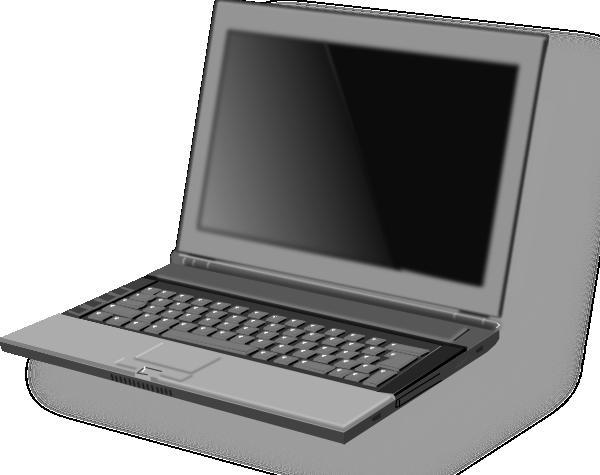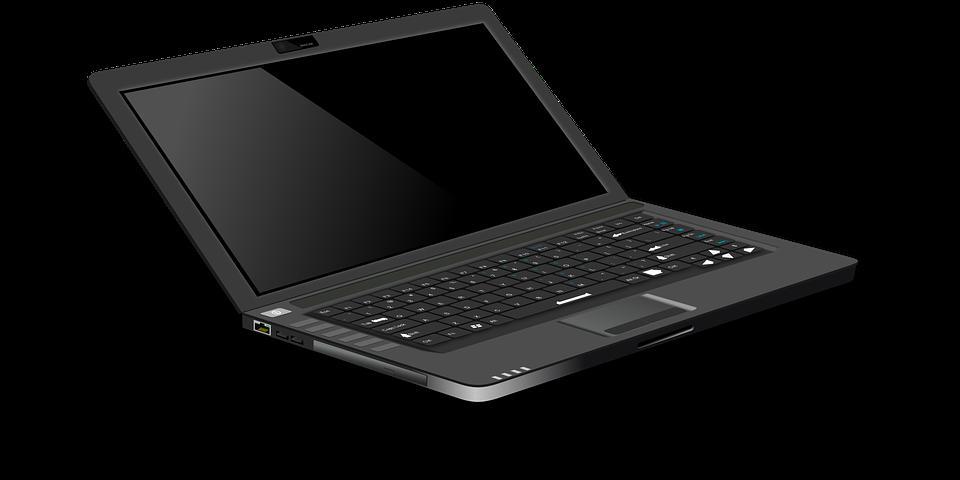The first image is the image on the left, the second image is the image on the right. Evaluate the accuracy of this statement regarding the images: "A laptop is shown with black background in one of the images.". Is it true? Answer yes or no. Yes. 